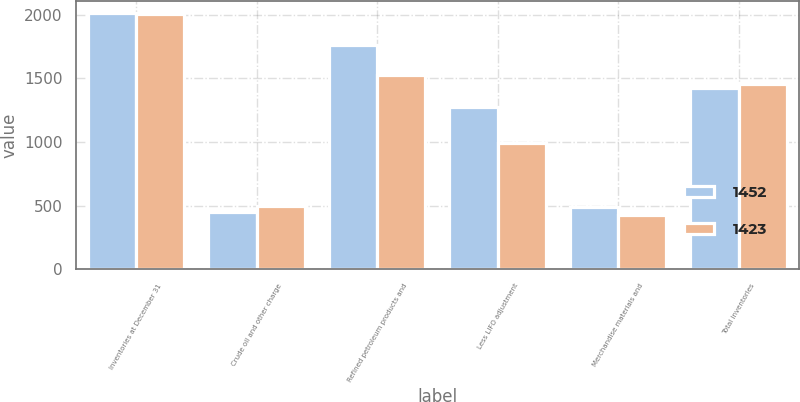Convert chart to OTSL. <chart><loc_0><loc_0><loc_500><loc_500><stacked_bar_chart><ecel><fcel>Inventories at December 31<fcel>Crude oil and other charge<fcel>Refined petroleum products and<fcel>Less LIFO adjustment<fcel>Merchandise materials and<fcel>Total inventories<nl><fcel>1452<fcel>2011<fcel>451<fcel>1762<fcel>1276<fcel>486<fcel>1423<nl><fcel>1423<fcel>2010<fcel>496<fcel>1528<fcel>995<fcel>423<fcel>1452<nl></chart> 